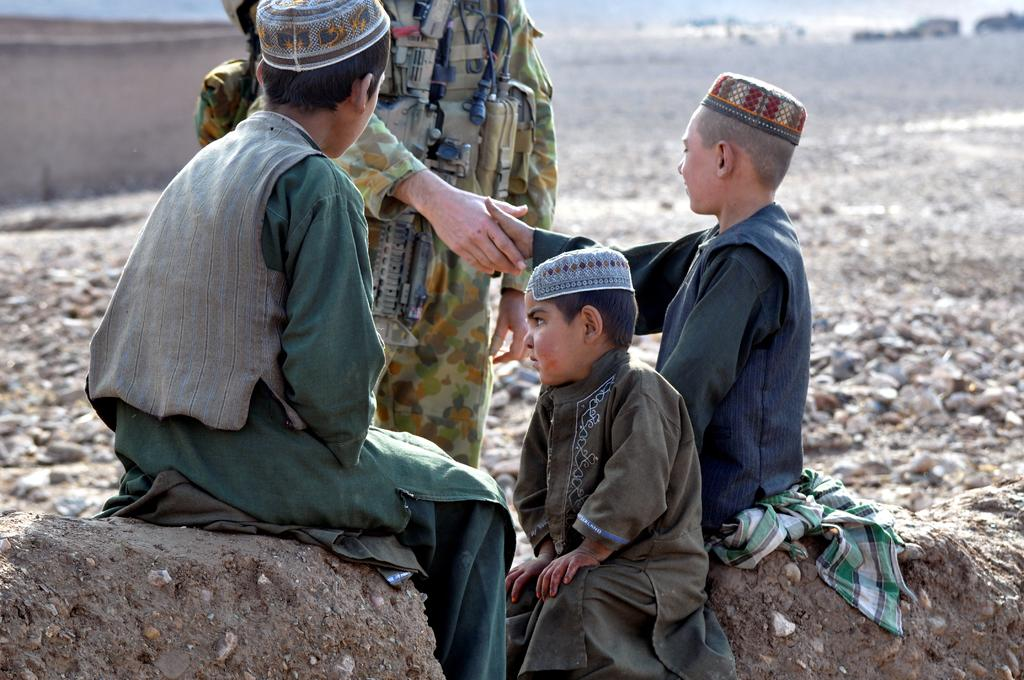How many boys are sitting in the image? There are three boys sitting in the image. What are the other people in the image doing? There are two people standing in the image, and two of them are handshaking. Can you describe the background of the image? The background of the image appears blurry. What type of terrain is visible in the image? Rocks are visible on the ground in the image. What type of fruit is the girl holding in the image? There is no girl present in the image, and therefore no fruit can be observed. Is there a river flowing in the background of the image? There is no river visible in the image; only rocks on the ground are present. 